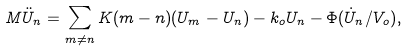Convert formula to latex. <formula><loc_0><loc_0><loc_500><loc_500>M \ddot { U } _ { n } = \sum _ { m \neq n } { K ( m - n ) ( U _ { m } - U _ { n } ) - k _ { o } U _ { n } - \Phi ( \dot { U } _ { n } / V _ { o } ) } ,</formula> 